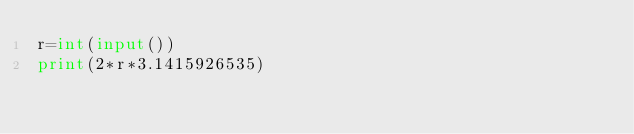Convert code to text. <code><loc_0><loc_0><loc_500><loc_500><_Python_>r=int(input())
print(2*r*3.1415926535)</code> 